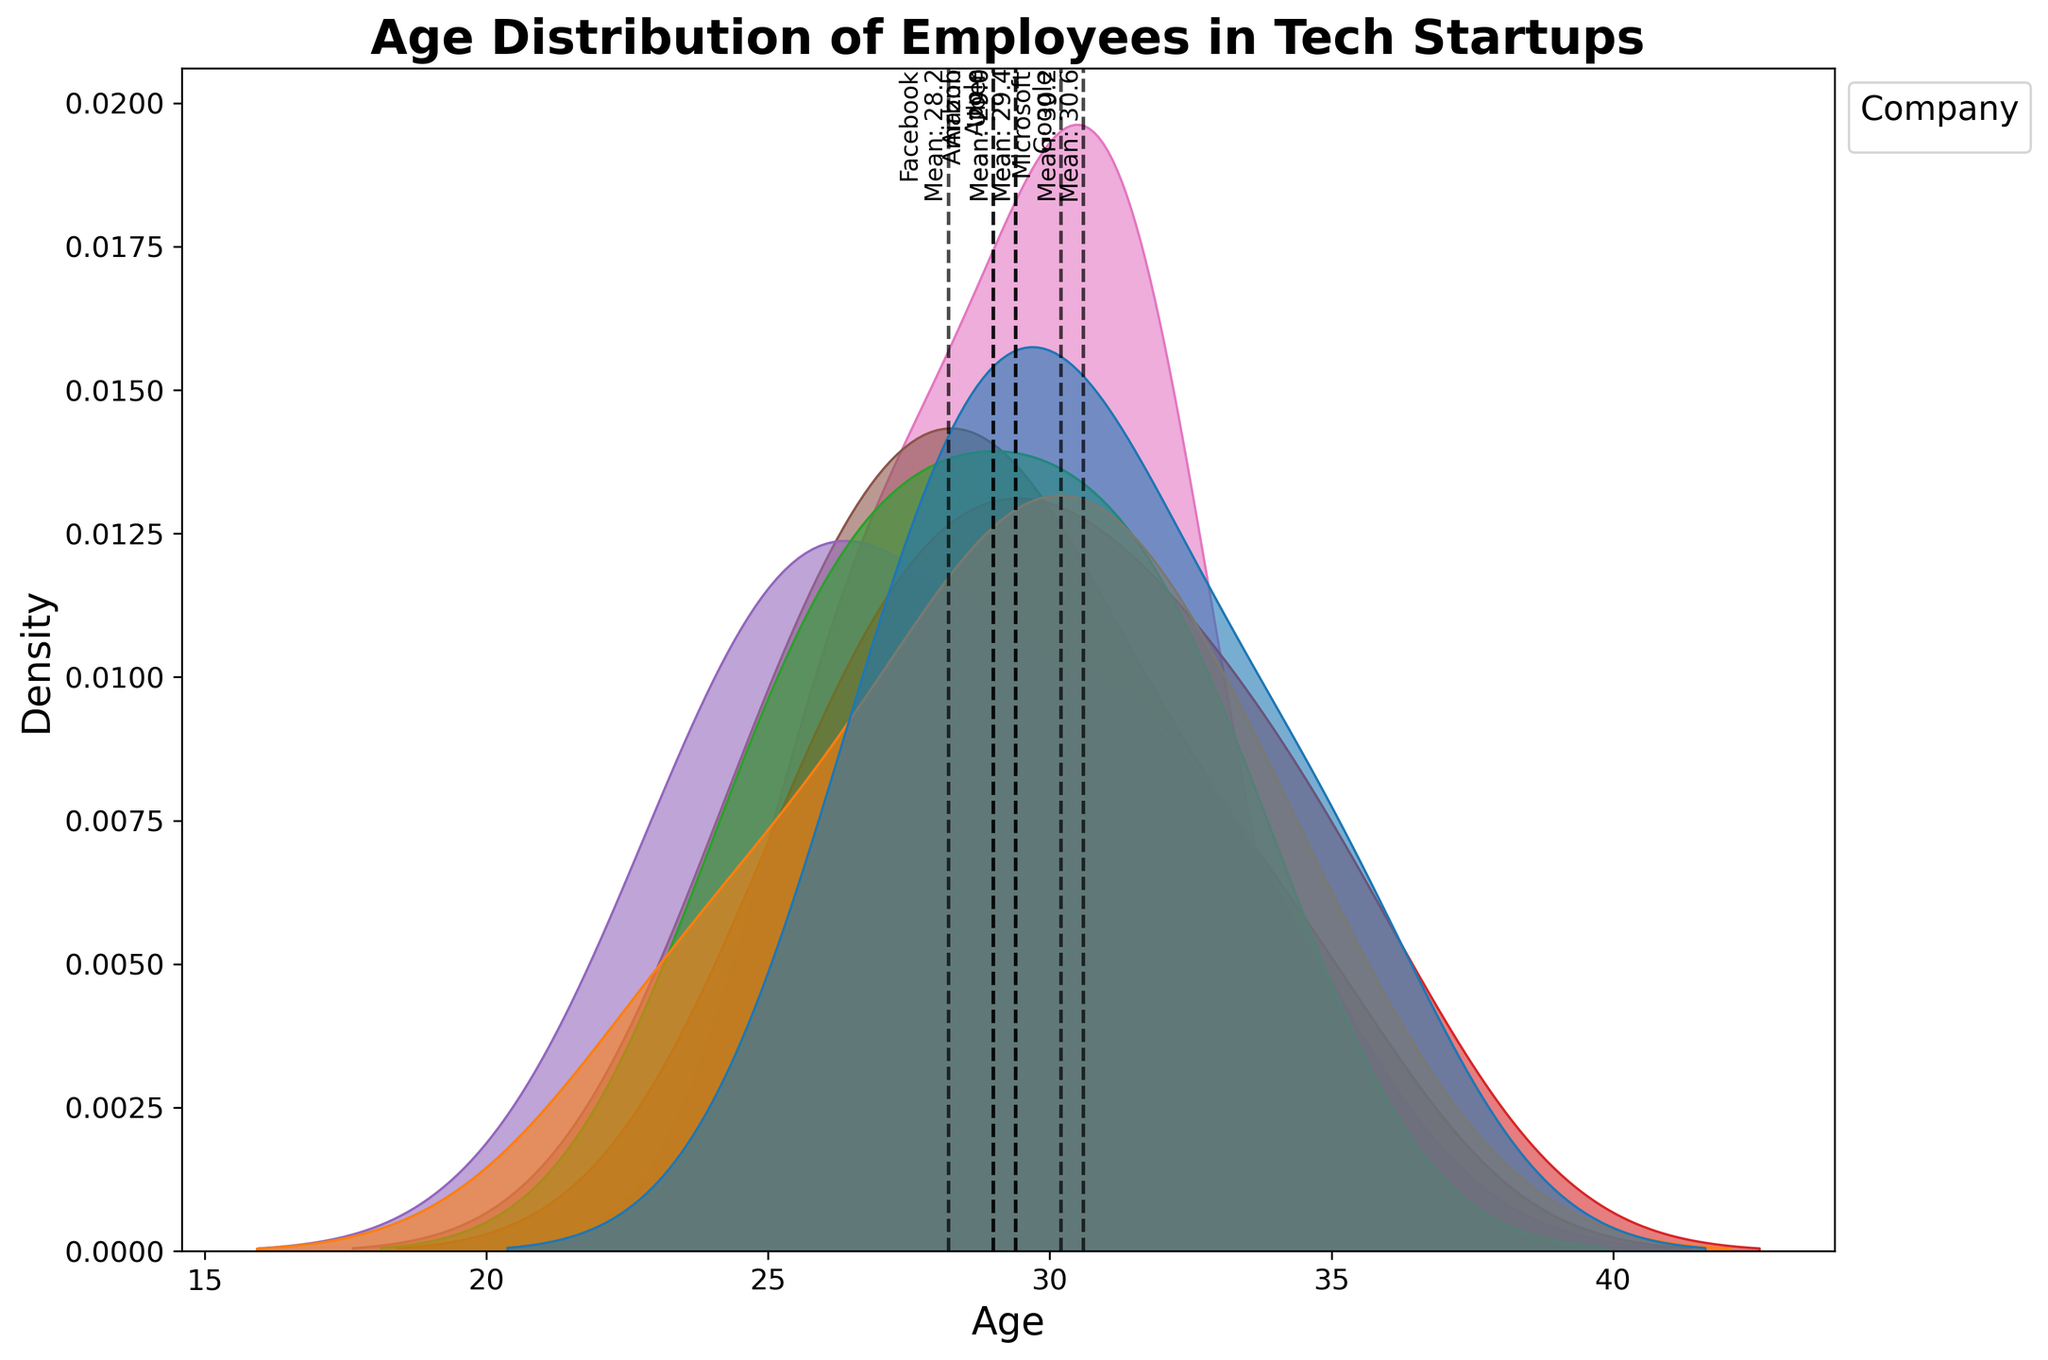what's the title of the plot? The title of the plot is located at the top of the figure, it is meant to provide an overview of what the plot represents.
Answer: Age Distribution of Employees in Tech Startups what's the x-axis label? The label for the x-axis is usually found below the x-axis and indicates what variable the axis represents.
Answer: Age which company has the highest mean age of employees? To find the company with the highest mean age of employees, look at the vertical dashed lines labeled with mean values and see which extends furthest to the right.
Answer: Microsoft compare the mean age of employees between Google and Apple? Identify the vertical dashed lines for Google and Apple, labeled with their mean values, and compare the positions on the x-axis.
Answer: Google's mean age is higher than Apple's why are there vertical dashed lines on the plot? Vertical dashed lines represent the mean age of employees for each company, providing a quick visual reference for comparing average ages.
Answer: They represent mean ages which company has the most even spread of employee ages? To determine the most even spread, look for the company with a density curve that is wide and not sharply peaked, indicating a broader range of ages.
Answer: Amazon how many different companies are represented in the plot? Count the distinct hues in the legend to find the number of unique companies represented.
Answer: 7 what density represents the youngest employees? Look for the peaks of the density curves on the leftmost side of the x-axis to identify where the youngest employees are.
Answer: Facebook or Apple is there a common age range shared by most companies? Identify the overlapping regions of the density plots to find the age range that covers most companies.
Answer: 28-32 which company has the least dense population of employees aged 25? Inspect the density curves at the age of 25 to see which company has the smallest vertical height (density) at that point.
Answer: Google or Microsoft 